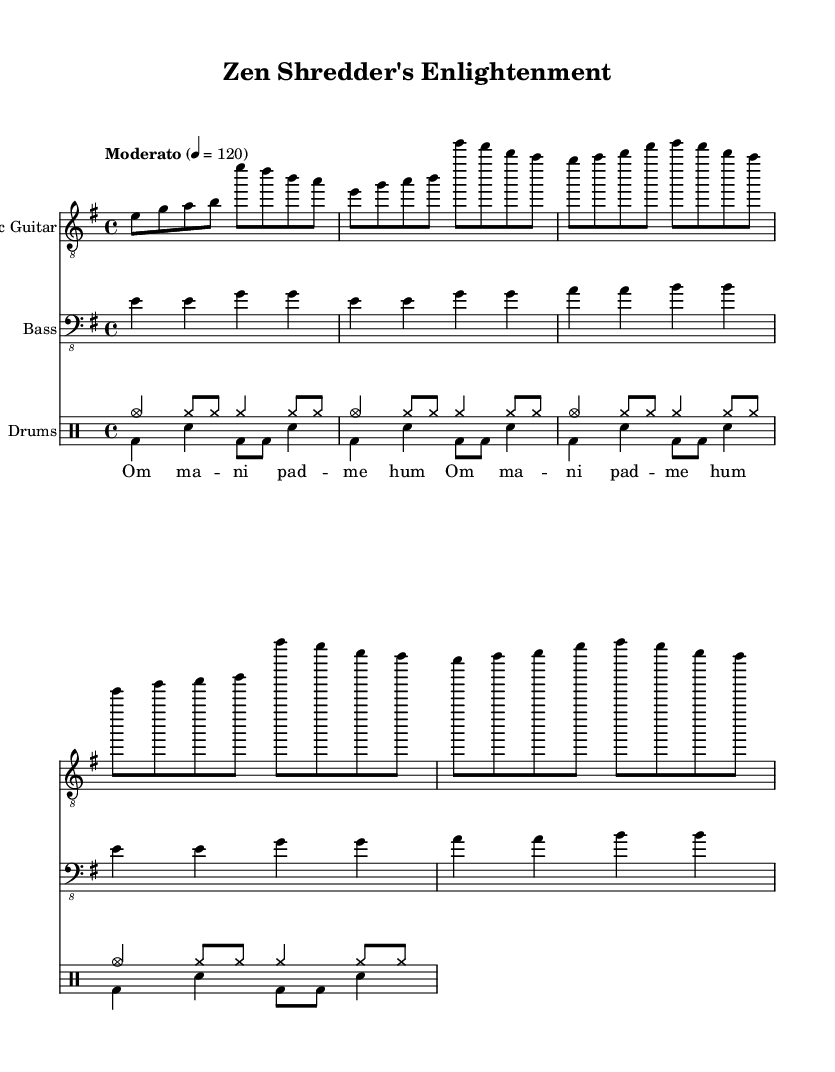What is the key signature of this music? The key signature is E minor, indicated by one sharp (F#) on the staff. E minor is the relative minor of G major and it is a common key for heavier styles, making it suitable for a heavy metal remix of Buddhist chants.
Answer: E minor What is the time signature of this music? The time signature is 4/4, which is often found in contemporary music styles, including heavy metal, allowing for a steady and driving rhythm suitable for the chanted lyrics.
Answer: 4/4 What is the tempo of this music? The tempo marking is "Moderato" with a speed of 120 beats per minute, which suggests a moderate pace that can promote both energy and focus, conducive for meditation while still retaining the intensity of heavy metal.
Answer: 120 How many measures are in the electric guitar part? The electric guitar part consists of four measures, all of which contain varying melodic phrases that repeat for the verse and chorus sections, contributing to the overall structure of the piece.
Answer: Four What are the lyrics chanted in the music? The lyrics consist of the phrase "Om mani padme hum," which is a well-known Buddhist mantra symbolizing compassion and enlightenment, and is prominently used throughout the piece.
Answer: Om mani padme hum Which instruments are featured in this music? The music features electric guitar, bass, and drums; each instrument contributes to the heavy metal remix and enhances the traditional Buddhist chants, emphasizing the fusion of religious and contemporary musical styles.
Answer: Electric guitar, bass, drums 